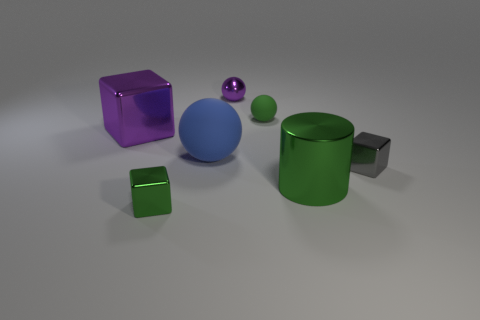How many other objects are the same shape as the big green metal thing?
Ensure brevity in your answer.  0. What is the color of the block that is right of the big blue sphere?
Offer a terse response. Gray. There is a tiny metal cube behind the small cube that is to the left of the tiny gray block; what number of tiny metal objects are left of it?
Your answer should be very brief. 2. How many objects are on the left side of the big metallic object that is in front of the large shiny block?
Ensure brevity in your answer.  5. How many tiny metallic things are in front of the purple shiny sphere?
Ensure brevity in your answer.  2. What number of other objects are the same size as the purple ball?
Provide a succinct answer. 3. There is a blue thing that is the same shape as the green matte object; what size is it?
Give a very brief answer. Large. There is a tiny green object that is behind the shiny cylinder; what is its shape?
Give a very brief answer. Sphere. What is the color of the cube in front of the green shiny thing to the right of the large blue object?
Keep it short and to the point. Green. How many objects are either small metallic blocks to the right of the green metal cylinder or large blue rubber blocks?
Provide a short and direct response. 1. 